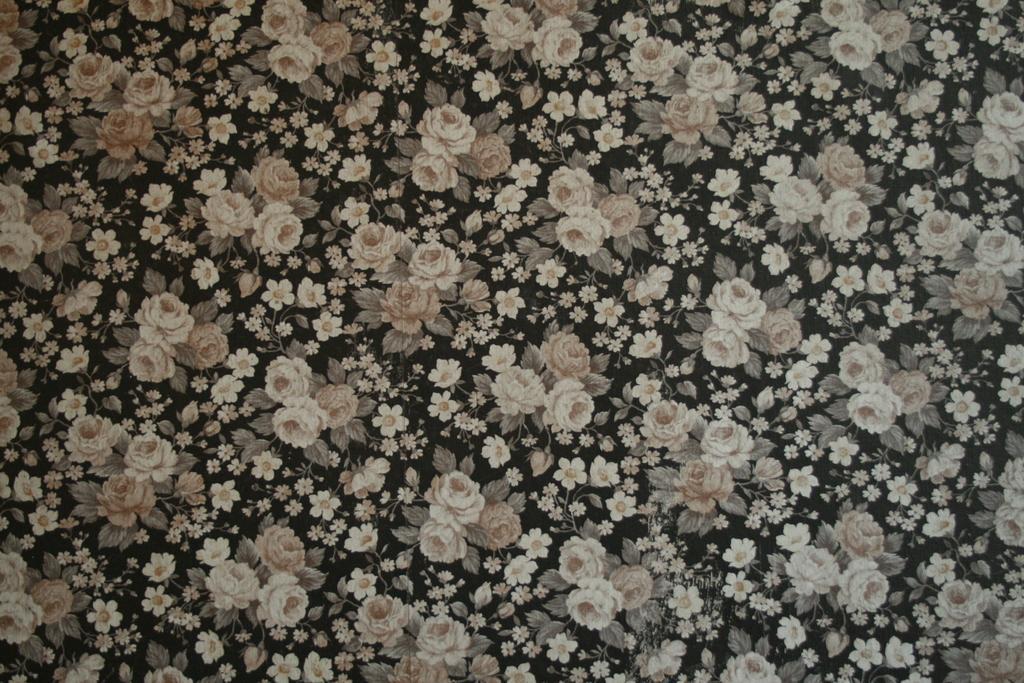In one or two sentences, can you explain what this image depicts? This picture shows that many white color flowers are printed on the black color fabric cloth. 